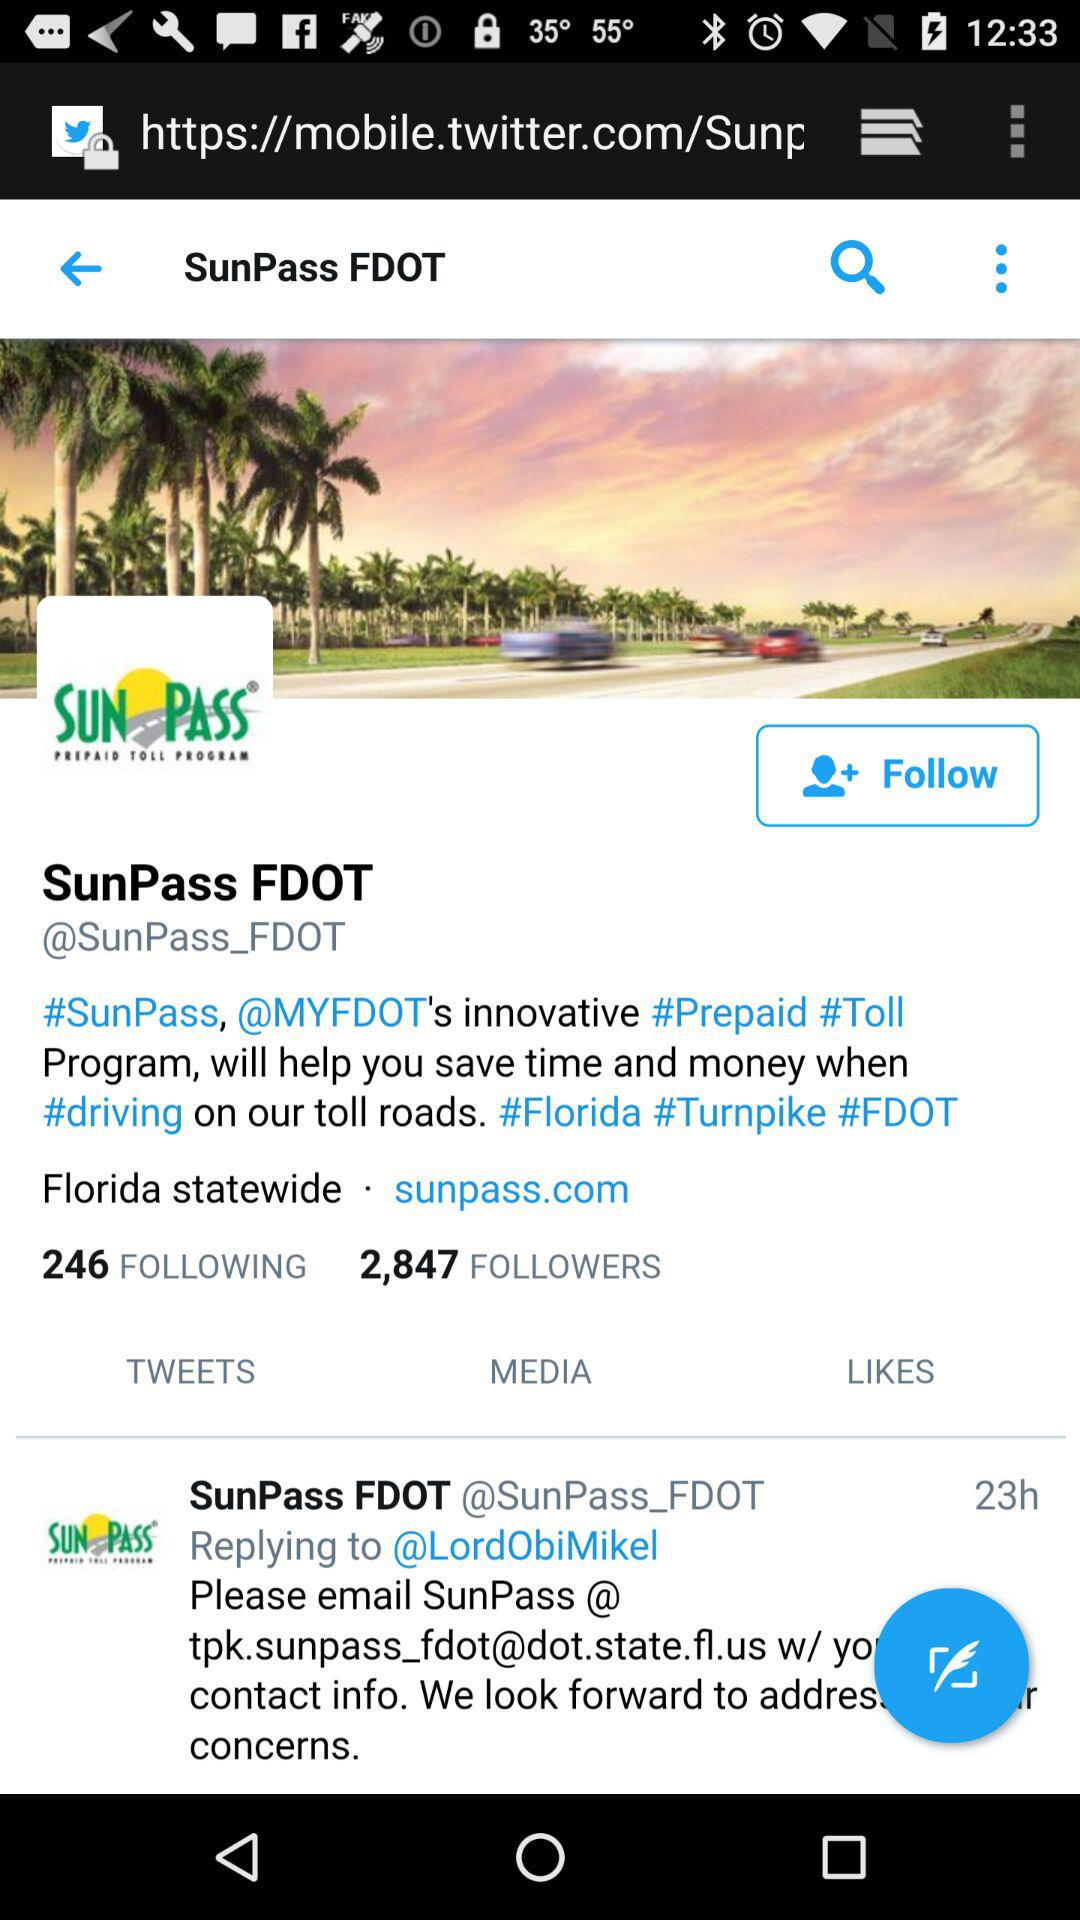What state is mentioned? The mentioned state is Florida. 